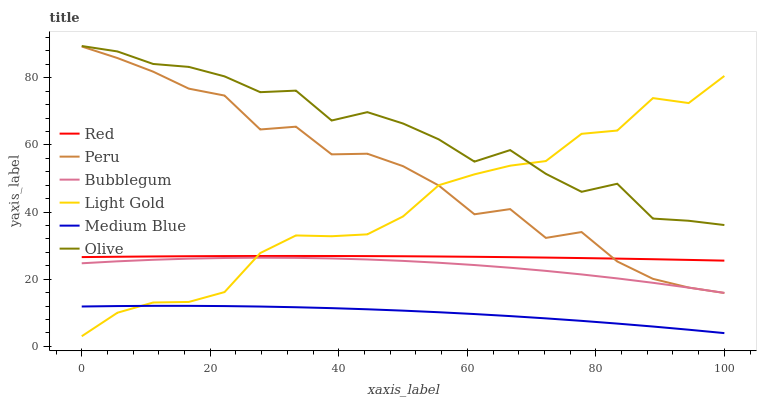Does Medium Blue have the minimum area under the curve?
Answer yes or no. Yes. Does Olive have the maximum area under the curve?
Answer yes or no. Yes. Does Bubblegum have the minimum area under the curve?
Answer yes or no. No. Does Bubblegum have the maximum area under the curve?
Answer yes or no. No. Is Red the smoothest?
Answer yes or no. Yes. Is Peru the roughest?
Answer yes or no. Yes. Is Bubblegum the smoothest?
Answer yes or no. No. Is Bubblegum the roughest?
Answer yes or no. No. Does Light Gold have the lowest value?
Answer yes or no. Yes. Does Bubblegum have the lowest value?
Answer yes or no. No. Does Olive have the highest value?
Answer yes or no. Yes. Does Bubblegum have the highest value?
Answer yes or no. No. Is Bubblegum less than Olive?
Answer yes or no. Yes. Is Olive greater than Red?
Answer yes or no. Yes. Does Light Gold intersect Bubblegum?
Answer yes or no. Yes. Is Light Gold less than Bubblegum?
Answer yes or no. No. Is Light Gold greater than Bubblegum?
Answer yes or no. No. Does Bubblegum intersect Olive?
Answer yes or no. No. 